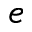Convert formula to latex. <formula><loc_0><loc_0><loc_500><loc_500>e</formula> 